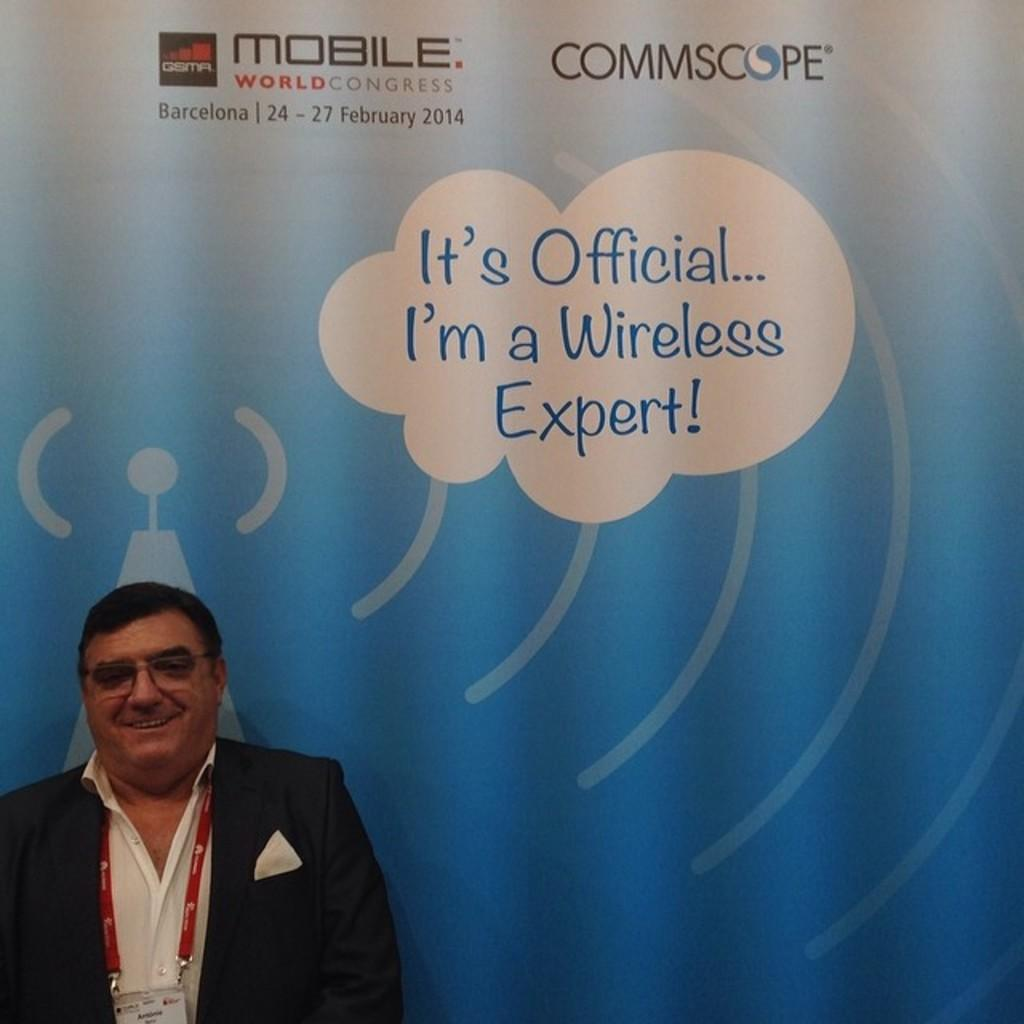<image>
Summarize the visual content of the image. A man wearing a suit stands in front of a Mobile World Congress conference poster in Barcelona 